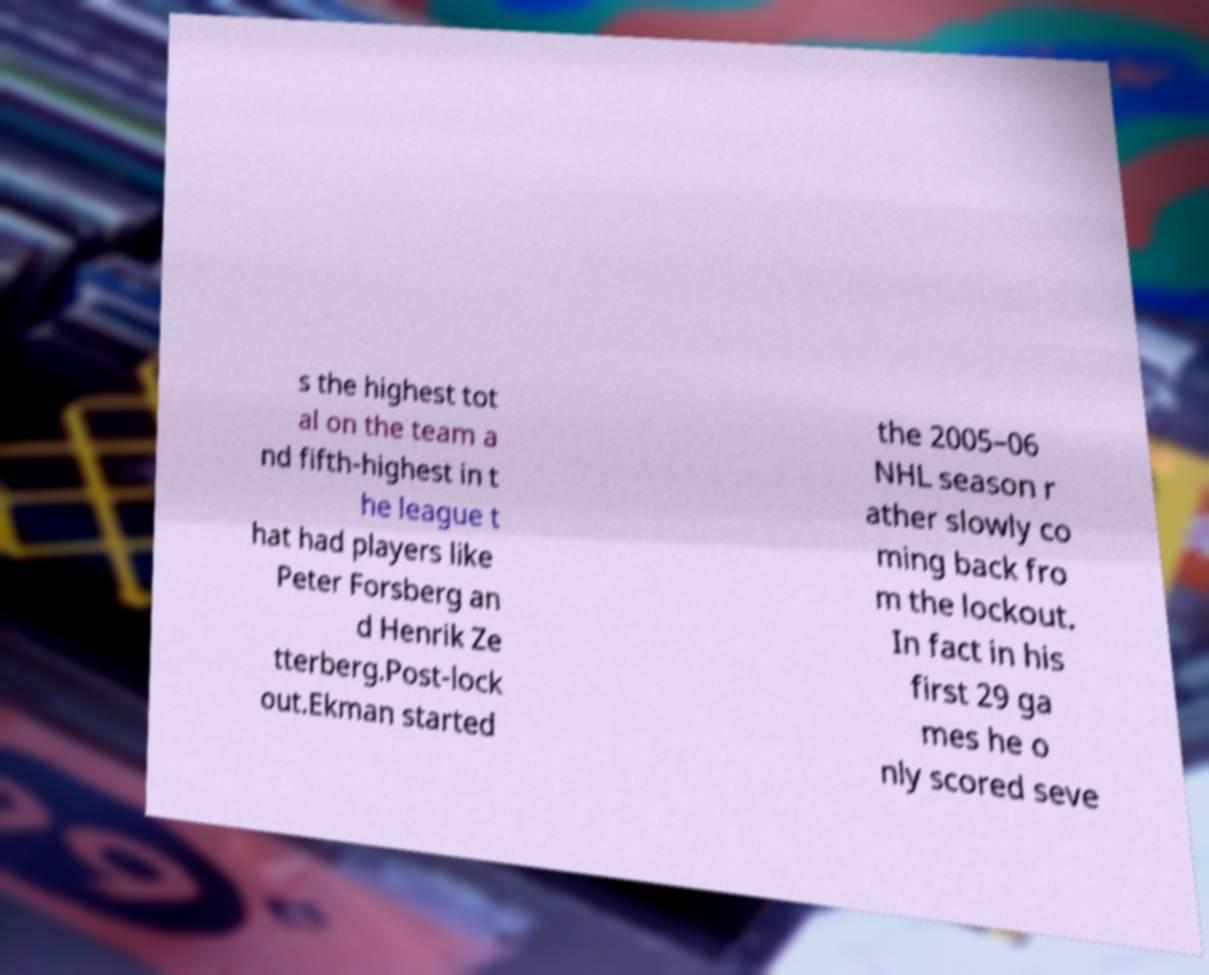What messages or text are displayed in this image? I need them in a readable, typed format. s the highest tot al on the team a nd fifth-highest in t he league t hat had players like Peter Forsberg an d Henrik Ze tterberg.Post-lock out.Ekman started the 2005–06 NHL season r ather slowly co ming back fro m the lockout. In fact in his first 29 ga mes he o nly scored seve 